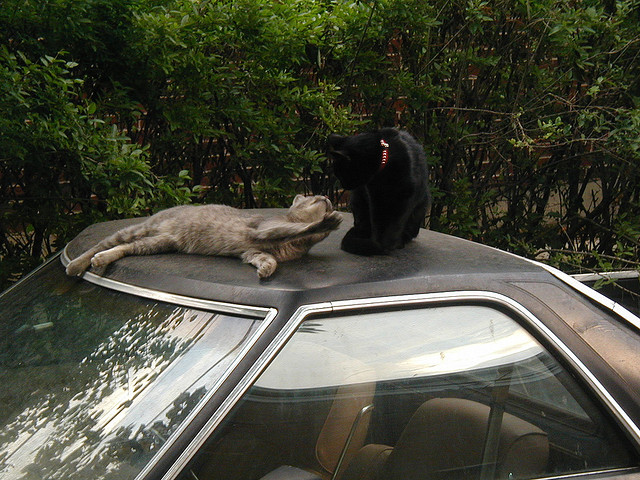<image>What are they doing? I don't know what they are doing. It might be playing, sitting, or resting. What are they doing? I am not sure what they are doing. It can be seen that they are sniffing each other, playing, sitting, laying, or resting. 